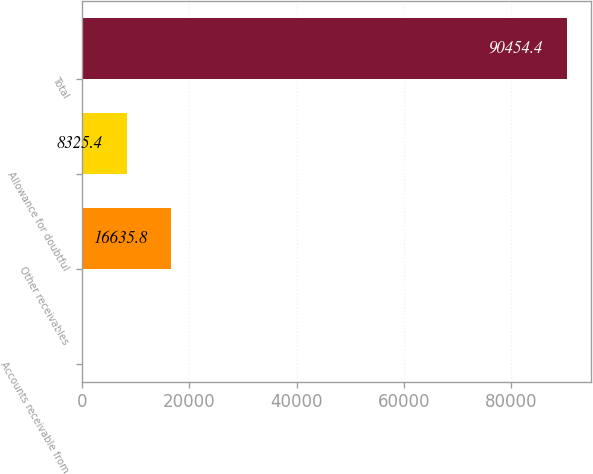Convert chart to OTSL. <chart><loc_0><loc_0><loc_500><loc_500><bar_chart><fcel>Accounts receivable from<fcel>Other receivables<fcel>Allowance for doubtful<fcel>Total<nl><fcel>15<fcel>16635.8<fcel>8325.4<fcel>90454.4<nl></chart> 